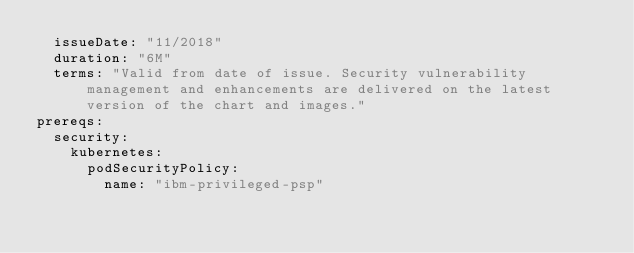<code> <loc_0><loc_0><loc_500><loc_500><_YAML_>  issueDate: "11/2018"
  duration: "6M"
  terms: "Valid from date of issue. Security vulnerability management and enhancements are delivered on the latest version of the chart and images."
prereqs:
  security:
    kubernetes: 
      podSecurityPolicy: 
        name: "ibm-privileged-psp"</code> 